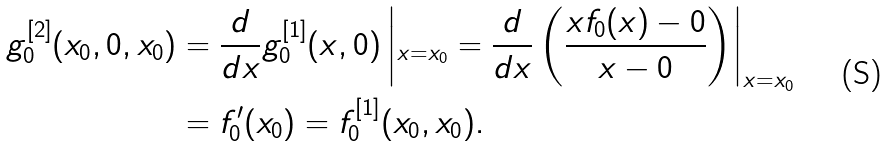Convert formula to latex. <formula><loc_0><loc_0><loc_500><loc_500>g _ { 0 } ^ { [ 2 ] } ( x _ { 0 } , 0 , x _ { 0 } ) & = \frac { d } { d x } g _ { 0 } ^ { [ 1 ] } ( x , 0 ) \left | _ { x = x _ { 0 } } = \frac { d } { d x } \left ( \frac { x f _ { 0 } ( x ) - 0 } { x - 0 } \right ) \right | _ { x = x _ { 0 } } \\ & = f ^ { \prime } _ { 0 } ( x _ { 0 } ) = f ^ { [ 1 ] } _ { 0 } ( x _ { 0 } , x _ { 0 } ) .</formula> 